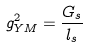Convert formula to latex. <formula><loc_0><loc_0><loc_500><loc_500>g _ { Y M } ^ { 2 } = \frac { G _ { s } } { l _ { s } }</formula> 